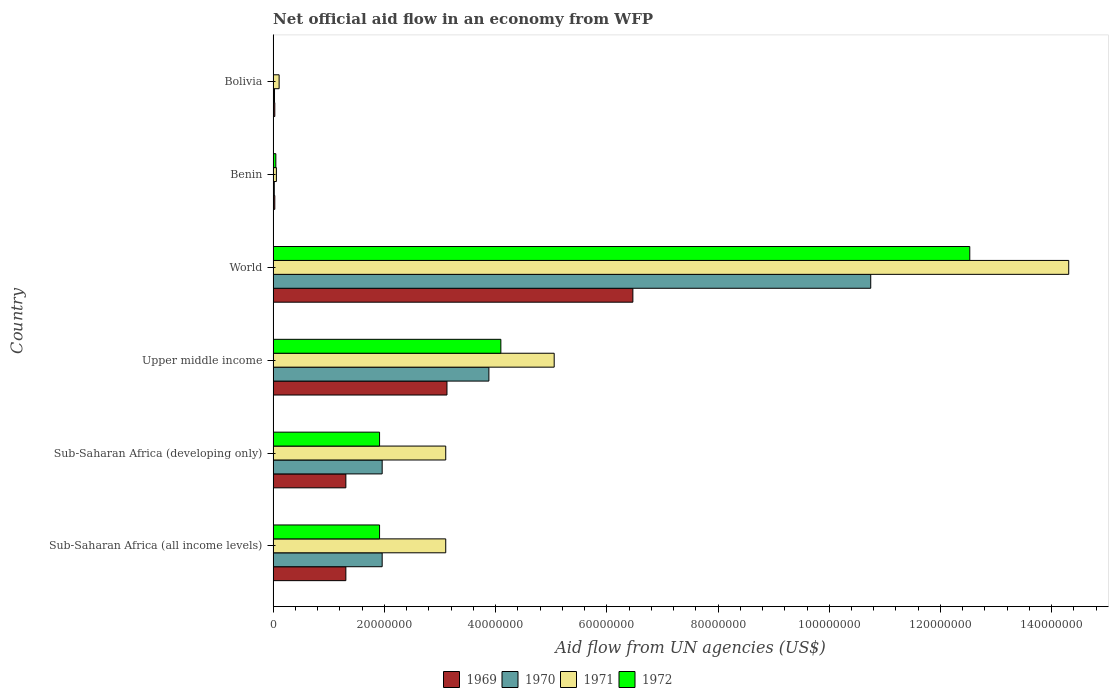How many different coloured bars are there?
Keep it short and to the point. 4. Are the number of bars per tick equal to the number of legend labels?
Provide a short and direct response. No. How many bars are there on the 3rd tick from the top?
Keep it short and to the point. 4. How many bars are there on the 2nd tick from the bottom?
Your answer should be compact. 4. What is the label of the 3rd group of bars from the top?
Offer a very short reply. World. What is the net official aid flow in 1969 in Sub-Saharan Africa (developing only)?
Your response must be concise. 1.31e+07. Across all countries, what is the maximum net official aid flow in 1971?
Your response must be concise. 1.43e+08. Across all countries, what is the minimum net official aid flow in 1969?
Give a very brief answer. 3.00e+05. In which country was the net official aid flow in 1972 maximum?
Offer a very short reply. World. What is the total net official aid flow in 1969 in the graph?
Offer a very short reply. 1.23e+08. What is the difference between the net official aid flow in 1969 in Bolivia and that in Sub-Saharan Africa (all income levels)?
Ensure brevity in your answer.  -1.28e+07. What is the difference between the net official aid flow in 1971 in Bolivia and the net official aid flow in 1970 in Upper middle income?
Keep it short and to the point. -3.77e+07. What is the average net official aid flow in 1970 per country?
Ensure brevity in your answer.  3.10e+07. In how many countries, is the net official aid flow in 1969 greater than 112000000 US$?
Provide a succinct answer. 0. What is the ratio of the net official aid flow in 1972 in Sub-Saharan Africa (developing only) to that in Upper middle income?
Provide a succinct answer. 0.47. Is the net official aid flow in 1972 in Benin less than that in Upper middle income?
Give a very brief answer. Yes. What is the difference between the highest and the second highest net official aid flow in 1969?
Provide a short and direct response. 3.34e+07. What is the difference between the highest and the lowest net official aid flow in 1972?
Give a very brief answer. 1.25e+08. Is the sum of the net official aid flow in 1970 in Sub-Saharan Africa (all income levels) and Sub-Saharan Africa (developing only) greater than the maximum net official aid flow in 1972 across all countries?
Give a very brief answer. No. How many bars are there?
Your answer should be compact. 23. How many countries are there in the graph?
Keep it short and to the point. 6. Are the values on the major ticks of X-axis written in scientific E-notation?
Keep it short and to the point. No. How many legend labels are there?
Ensure brevity in your answer.  4. What is the title of the graph?
Provide a short and direct response. Net official aid flow in an economy from WFP. What is the label or title of the X-axis?
Your response must be concise. Aid flow from UN agencies (US$). What is the Aid flow from UN agencies (US$) of 1969 in Sub-Saharan Africa (all income levels)?
Your answer should be very brief. 1.31e+07. What is the Aid flow from UN agencies (US$) of 1970 in Sub-Saharan Africa (all income levels)?
Ensure brevity in your answer.  1.96e+07. What is the Aid flow from UN agencies (US$) in 1971 in Sub-Saharan Africa (all income levels)?
Your answer should be compact. 3.10e+07. What is the Aid flow from UN agencies (US$) in 1972 in Sub-Saharan Africa (all income levels)?
Your response must be concise. 1.91e+07. What is the Aid flow from UN agencies (US$) of 1969 in Sub-Saharan Africa (developing only)?
Provide a succinct answer. 1.31e+07. What is the Aid flow from UN agencies (US$) in 1970 in Sub-Saharan Africa (developing only)?
Your response must be concise. 1.96e+07. What is the Aid flow from UN agencies (US$) of 1971 in Sub-Saharan Africa (developing only)?
Make the answer very short. 3.10e+07. What is the Aid flow from UN agencies (US$) in 1972 in Sub-Saharan Africa (developing only)?
Provide a succinct answer. 1.91e+07. What is the Aid flow from UN agencies (US$) of 1969 in Upper middle income?
Keep it short and to the point. 3.13e+07. What is the Aid flow from UN agencies (US$) in 1970 in Upper middle income?
Keep it short and to the point. 3.88e+07. What is the Aid flow from UN agencies (US$) of 1971 in Upper middle income?
Offer a very short reply. 5.05e+07. What is the Aid flow from UN agencies (US$) in 1972 in Upper middle income?
Offer a very short reply. 4.10e+07. What is the Aid flow from UN agencies (US$) of 1969 in World?
Offer a terse response. 6.47e+07. What is the Aid flow from UN agencies (US$) of 1970 in World?
Your response must be concise. 1.07e+08. What is the Aid flow from UN agencies (US$) of 1971 in World?
Keep it short and to the point. 1.43e+08. What is the Aid flow from UN agencies (US$) of 1972 in World?
Offer a very short reply. 1.25e+08. What is the Aid flow from UN agencies (US$) of 1971 in Benin?
Make the answer very short. 5.90e+05. What is the Aid flow from UN agencies (US$) in 1972 in Benin?
Make the answer very short. 4.90e+05. What is the Aid flow from UN agencies (US$) in 1970 in Bolivia?
Your response must be concise. 2.50e+05. What is the Aid flow from UN agencies (US$) of 1971 in Bolivia?
Your answer should be very brief. 1.08e+06. Across all countries, what is the maximum Aid flow from UN agencies (US$) of 1969?
Provide a short and direct response. 6.47e+07. Across all countries, what is the maximum Aid flow from UN agencies (US$) in 1970?
Keep it short and to the point. 1.07e+08. Across all countries, what is the maximum Aid flow from UN agencies (US$) in 1971?
Keep it short and to the point. 1.43e+08. Across all countries, what is the maximum Aid flow from UN agencies (US$) of 1972?
Ensure brevity in your answer.  1.25e+08. Across all countries, what is the minimum Aid flow from UN agencies (US$) of 1970?
Your response must be concise. 2.10e+05. Across all countries, what is the minimum Aid flow from UN agencies (US$) of 1971?
Keep it short and to the point. 5.90e+05. Across all countries, what is the minimum Aid flow from UN agencies (US$) of 1972?
Offer a terse response. 0. What is the total Aid flow from UN agencies (US$) in 1969 in the graph?
Ensure brevity in your answer.  1.23e+08. What is the total Aid flow from UN agencies (US$) in 1970 in the graph?
Keep it short and to the point. 1.86e+08. What is the total Aid flow from UN agencies (US$) of 1971 in the graph?
Your answer should be compact. 2.57e+08. What is the total Aid flow from UN agencies (US$) of 1972 in the graph?
Offer a very short reply. 2.05e+08. What is the difference between the Aid flow from UN agencies (US$) in 1969 in Sub-Saharan Africa (all income levels) and that in Sub-Saharan Africa (developing only)?
Give a very brief answer. 0. What is the difference between the Aid flow from UN agencies (US$) in 1969 in Sub-Saharan Africa (all income levels) and that in Upper middle income?
Your response must be concise. -1.82e+07. What is the difference between the Aid flow from UN agencies (US$) in 1970 in Sub-Saharan Africa (all income levels) and that in Upper middle income?
Offer a terse response. -1.92e+07. What is the difference between the Aid flow from UN agencies (US$) of 1971 in Sub-Saharan Africa (all income levels) and that in Upper middle income?
Offer a terse response. -1.95e+07. What is the difference between the Aid flow from UN agencies (US$) of 1972 in Sub-Saharan Africa (all income levels) and that in Upper middle income?
Ensure brevity in your answer.  -2.18e+07. What is the difference between the Aid flow from UN agencies (US$) of 1969 in Sub-Saharan Africa (all income levels) and that in World?
Give a very brief answer. -5.16e+07. What is the difference between the Aid flow from UN agencies (US$) in 1970 in Sub-Saharan Africa (all income levels) and that in World?
Your response must be concise. -8.78e+07. What is the difference between the Aid flow from UN agencies (US$) of 1971 in Sub-Saharan Africa (all income levels) and that in World?
Provide a succinct answer. -1.12e+08. What is the difference between the Aid flow from UN agencies (US$) in 1972 in Sub-Saharan Africa (all income levels) and that in World?
Ensure brevity in your answer.  -1.06e+08. What is the difference between the Aid flow from UN agencies (US$) of 1969 in Sub-Saharan Africa (all income levels) and that in Benin?
Give a very brief answer. 1.28e+07. What is the difference between the Aid flow from UN agencies (US$) of 1970 in Sub-Saharan Africa (all income levels) and that in Benin?
Give a very brief answer. 1.94e+07. What is the difference between the Aid flow from UN agencies (US$) of 1971 in Sub-Saharan Africa (all income levels) and that in Benin?
Your response must be concise. 3.04e+07. What is the difference between the Aid flow from UN agencies (US$) of 1972 in Sub-Saharan Africa (all income levels) and that in Benin?
Offer a very short reply. 1.86e+07. What is the difference between the Aid flow from UN agencies (US$) of 1969 in Sub-Saharan Africa (all income levels) and that in Bolivia?
Offer a very short reply. 1.28e+07. What is the difference between the Aid flow from UN agencies (US$) in 1970 in Sub-Saharan Africa (all income levels) and that in Bolivia?
Keep it short and to the point. 1.94e+07. What is the difference between the Aid flow from UN agencies (US$) of 1971 in Sub-Saharan Africa (all income levels) and that in Bolivia?
Ensure brevity in your answer.  3.00e+07. What is the difference between the Aid flow from UN agencies (US$) in 1969 in Sub-Saharan Africa (developing only) and that in Upper middle income?
Your answer should be compact. -1.82e+07. What is the difference between the Aid flow from UN agencies (US$) in 1970 in Sub-Saharan Africa (developing only) and that in Upper middle income?
Your answer should be very brief. -1.92e+07. What is the difference between the Aid flow from UN agencies (US$) in 1971 in Sub-Saharan Africa (developing only) and that in Upper middle income?
Provide a succinct answer. -1.95e+07. What is the difference between the Aid flow from UN agencies (US$) in 1972 in Sub-Saharan Africa (developing only) and that in Upper middle income?
Ensure brevity in your answer.  -2.18e+07. What is the difference between the Aid flow from UN agencies (US$) of 1969 in Sub-Saharan Africa (developing only) and that in World?
Make the answer very short. -5.16e+07. What is the difference between the Aid flow from UN agencies (US$) in 1970 in Sub-Saharan Africa (developing only) and that in World?
Offer a very short reply. -8.78e+07. What is the difference between the Aid flow from UN agencies (US$) in 1971 in Sub-Saharan Africa (developing only) and that in World?
Your answer should be very brief. -1.12e+08. What is the difference between the Aid flow from UN agencies (US$) in 1972 in Sub-Saharan Africa (developing only) and that in World?
Provide a short and direct response. -1.06e+08. What is the difference between the Aid flow from UN agencies (US$) in 1969 in Sub-Saharan Africa (developing only) and that in Benin?
Make the answer very short. 1.28e+07. What is the difference between the Aid flow from UN agencies (US$) of 1970 in Sub-Saharan Africa (developing only) and that in Benin?
Offer a terse response. 1.94e+07. What is the difference between the Aid flow from UN agencies (US$) in 1971 in Sub-Saharan Africa (developing only) and that in Benin?
Offer a very short reply. 3.04e+07. What is the difference between the Aid flow from UN agencies (US$) of 1972 in Sub-Saharan Africa (developing only) and that in Benin?
Offer a very short reply. 1.86e+07. What is the difference between the Aid flow from UN agencies (US$) in 1969 in Sub-Saharan Africa (developing only) and that in Bolivia?
Keep it short and to the point. 1.28e+07. What is the difference between the Aid flow from UN agencies (US$) in 1970 in Sub-Saharan Africa (developing only) and that in Bolivia?
Provide a succinct answer. 1.94e+07. What is the difference between the Aid flow from UN agencies (US$) in 1971 in Sub-Saharan Africa (developing only) and that in Bolivia?
Ensure brevity in your answer.  3.00e+07. What is the difference between the Aid flow from UN agencies (US$) of 1969 in Upper middle income and that in World?
Keep it short and to the point. -3.34e+07. What is the difference between the Aid flow from UN agencies (US$) of 1970 in Upper middle income and that in World?
Offer a terse response. -6.87e+07. What is the difference between the Aid flow from UN agencies (US$) of 1971 in Upper middle income and that in World?
Give a very brief answer. -9.25e+07. What is the difference between the Aid flow from UN agencies (US$) of 1972 in Upper middle income and that in World?
Your answer should be compact. -8.43e+07. What is the difference between the Aid flow from UN agencies (US$) of 1969 in Upper middle income and that in Benin?
Your answer should be very brief. 3.10e+07. What is the difference between the Aid flow from UN agencies (US$) in 1970 in Upper middle income and that in Benin?
Keep it short and to the point. 3.86e+07. What is the difference between the Aid flow from UN agencies (US$) of 1971 in Upper middle income and that in Benin?
Your answer should be compact. 5.00e+07. What is the difference between the Aid flow from UN agencies (US$) in 1972 in Upper middle income and that in Benin?
Your answer should be compact. 4.05e+07. What is the difference between the Aid flow from UN agencies (US$) in 1969 in Upper middle income and that in Bolivia?
Your answer should be compact. 3.10e+07. What is the difference between the Aid flow from UN agencies (US$) of 1970 in Upper middle income and that in Bolivia?
Offer a terse response. 3.86e+07. What is the difference between the Aid flow from UN agencies (US$) in 1971 in Upper middle income and that in Bolivia?
Keep it short and to the point. 4.95e+07. What is the difference between the Aid flow from UN agencies (US$) in 1969 in World and that in Benin?
Your answer should be very brief. 6.44e+07. What is the difference between the Aid flow from UN agencies (US$) in 1970 in World and that in Benin?
Offer a very short reply. 1.07e+08. What is the difference between the Aid flow from UN agencies (US$) of 1971 in World and that in Benin?
Ensure brevity in your answer.  1.42e+08. What is the difference between the Aid flow from UN agencies (US$) of 1972 in World and that in Benin?
Offer a terse response. 1.25e+08. What is the difference between the Aid flow from UN agencies (US$) of 1969 in World and that in Bolivia?
Your answer should be compact. 6.44e+07. What is the difference between the Aid flow from UN agencies (US$) in 1970 in World and that in Bolivia?
Your answer should be very brief. 1.07e+08. What is the difference between the Aid flow from UN agencies (US$) of 1971 in World and that in Bolivia?
Your response must be concise. 1.42e+08. What is the difference between the Aid flow from UN agencies (US$) in 1969 in Benin and that in Bolivia?
Make the answer very short. 0. What is the difference between the Aid flow from UN agencies (US$) of 1970 in Benin and that in Bolivia?
Offer a terse response. -4.00e+04. What is the difference between the Aid flow from UN agencies (US$) of 1971 in Benin and that in Bolivia?
Provide a succinct answer. -4.90e+05. What is the difference between the Aid flow from UN agencies (US$) in 1969 in Sub-Saharan Africa (all income levels) and the Aid flow from UN agencies (US$) in 1970 in Sub-Saharan Africa (developing only)?
Make the answer very short. -6.53e+06. What is the difference between the Aid flow from UN agencies (US$) in 1969 in Sub-Saharan Africa (all income levels) and the Aid flow from UN agencies (US$) in 1971 in Sub-Saharan Africa (developing only)?
Provide a short and direct response. -1.80e+07. What is the difference between the Aid flow from UN agencies (US$) in 1969 in Sub-Saharan Africa (all income levels) and the Aid flow from UN agencies (US$) in 1972 in Sub-Saharan Africa (developing only)?
Provide a short and direct response. -6.06e+06. What is the difference between the Aid flow from UN agencies (US$) in 1970 in Sub-Saharan Africa (all income levels) and the Aid flow from UN agencies (US$) in 1971 in Sub-Saharan Africa (developing only)?
Your answer should be compact. -1.14e+07. What is the difference between the Aid flow from UN agencies (US$) of 1970 in Sub-Saharan Africa (all income levels) and the Aid flow from UN agencies (US$) of 1972 in Sub-Saharan Africa (developing only)?
Make the answer very short. 4.70e+05. What is the difference between the Aid flow from UN agencies (US$) in 1971 in Sub-Saharan Africa (all income levels) and the Aid flow from UN agencies (US$) in 1972 in Sub-Saharan Africa (developing only)?
Your answer should be very brief. 1.19e+07. What is the difference between the Aid flow from UN agencies (US$) of 1969 in Sub-Saharan Africa (all income levels) and the Aid flow from UN agencies (US$) of 1970 in Upper middle income?
Offer a very short reply. -2.57e+07. What is the difference between the Aid flow from UN agencies (US$) in 1969 in Sub-Saharan Africa (all income levels) and the Aid flow from UN agencies (US$) in 1971 in Upper middle income?
Offer a terse response. -3.75e+07. What is the difference between the Aid flow from UN agencies (US$) of 1969 in Sub-Saharan Africa (all income levels) and the Aid flow from UN agencies (US$) of 1972 in Upper middle income?
Offer a terse response. -2.79e+07. What is the difference between the Aid flow from UN agencies (US$) of 1970 in Sub-Saharan Africa (all income levels) and the Aid flow from UN agencies (US$) of 1971 in Upper middle income?
Provide a succinct answer. -3.09e+07. What is the difference between the Aid flow from UN agencies (US$) of 1970 in Sub-Saharan Africa (all income levels) and the Aid flow from UN agencies (US$) of 1972 in Upper middle income?
Provide a short and direct response. -2.13e+07. What is the difference between the Aid flow from UN agencies (US$) in 1971 in Sub-Saharan Africa (all income levels) and the Aid flow from UN agencies (US$) in 1972 in Upper middle income?
Provide a succinct answer. -9.91e+06. What is the difference between the Aid flow from UN agencies (US$) in 1969 in Sub-Saharan Africa (all income levels) and the Aid flow from UN agencies (US$) in 1970 in World?
Offer a very short reply. -9.44e+07. What is the difference between the Aid flow from UN agencies (US$) of 1969 in Sub-Saharan Africa (all income levels) and the Aid flow from UN agencies (US$) of 1971 in World?
Ensure brevity in your answer.  -1.30e+08. What is the difference between the Aid flow from UN agencies (US$) in 1969 in Sub-Saharan Africa (all income levels) and the Aid flow from UN agencies (US$) in 1972 in World?
Offer a terse response. -1.12e+08. What is the difference between the Aid flow from UN agencies (US$) in 1970 in Sub-Saharan Africa (all income levels) and the Aid flow from UN agencies (US$) in 1971 in World?
Keep it short and to the point. -1.23e+08. What is the difference between the Aid flow from UN agencies (US$) in 1970 in Sub-Saharan Africa (all income levels) and the Aid flow from UN agencies (US$) in 1972 in World?
Give a very brief answer. -1.06e+08. What is the difference between the Aid flow from UN agencies (US$) of 1971 in Sub-Saharan Africa (all income levels) and the Aid flow from UN agencies (US$) of 1972 in World?
Offer a terse response. -9.42e+07. What is the difference between the Aid flow from UN agencies (US$) in 1969 in Sub-Saharan Africa (all income levels) and the Aid flow from UN agencies (US$) in 1970 in Benin?
Make the answer very short. 1.29e+07. What is the difference between the Aid flow from UN agencies (US$) in 1969 in Sub-Saharan Africa (all income levels) and the Aid flow from UN agencies (US$) in 1971 in Benin?
Your response must be concise. 1.25e+07. What is the difference between the Aid flow from UN agencies (US$) of 1969 in Sub-Saharan Africa (all income levels) and the Aid flow from UN agencies (US$) of 1972 in Benin?
Offer a very short reply. 1.26e+07. What is the difference between the Aid flow from UN agencies (US$) in 1970 in Sub-Saharan Africa (all income levels) and the Aid flow from UN agencies (US$) in 1971 in Benin?
Give a very brief answer. 1.90e+07. What is the difference between the Aid flow from UN agencies (US$) in 1970 in Sub-Saharan Africa (all income levels) and the Aid flow from UN agencies (US$) in 1972 in Benin?
Ensure brevity in your answer.  1.91e+07. What is the difference between the Aid flow from UN agencies (US$) of 1971 in Sub-Saharan Africa (all income levels) and the Aid flow from UN agencies (US$) of 1972 in Benin?
Your response must be concise. 3.06e+07. What is the difference between the Aid flow from UN agencies (US$) of 1969 in Sub-Saharan Africa (all income levels) and the Aid flow from UN agencies (US$) of 1970 in Bolivia?
Ensure brevity in your answer.  1.28e+07. What is the difference between the Aid flow from UN agencies (US$) in 1970 in Sub-Saharan Africa (all income levels) and the Aid flow from UN agencies (US$) in 1971 in Bolivia?
Offer a very short reply. 1.85e+07. What is the difference between the Aid flow from UN agencies (US$) of 1969 in Sub-Saharan Africa (developing only) and the Aid flow from UN agencies (US$) of 1970 in Upper middle income?
Your response must be concise. -2.57e+07. What is the difference between the Aid flow from UN agencies (US$) in 1969 in Sub-Saharan Africa (developing only) and the Aid flow from UN agencies (US$) in 1971 in Upper middle income?
Ensure brevity in your answer.  -3.75e+07. What is the difference between the Aid flow from UN agencies (US$) of 1969 in Sub-Saharan Africa (developing only) and the Aid flow from UN agencies (US$) of 1972 in Upper middle income?
Offer a very short reply. -2.79e+07. What is the difference between the Aid flow from UN agencies (US$) of 1970 in Sub-Saharan Africa (developing only) and the Aid flow from UN agencies (US$) of 1971 in Upper middle income?
Give a very brief answer. -3.09e+07. What is the difference between the Aid flow from UN agencies (US$) in 1970 in Sub-Saharan Africa (developing only) and the Aid flow from UN agencies (US$) in 1972 in Upper middle income?
Offer a very short reply. -2.13e+07. What is the difference between the Aid flow from UN agencies (US$) in 1971 in Sub-Saharan Africa (developing only) and the Aid flow from UN agencies (US$) in 1972 in Upper middle income?
Provide a short and direct response. -9.91e+06. What is the difference between the Aid flow from UN agencies (US$) of 1969 in Sub-Saharan Africa (developing only) and the Aid flow from UN agencies (US$) of 1970 in World?
Your answer should be very brief. -9.44e+07. What is the difference between the Aid flow from UN agencies (US$) in 1969 in Sub-Saharan Africa (developing only) and the Aid flow from UN agencies (US$) in 1971 in World?
Your answer should be very brief. -1.30e+08. What is the difference between the Aid flow from UN agencies (US$) of 1969 in Sub-Saharan Africa (developing only) and the Aid flow from UN agencies (US$) of 1972 in World?
Ensure brevity in your answer.  -1.12e+08. What is the difference between the Aid flow from UN agencies (US$) in 1970 in Sub-Saharan Africa (developing only) and the Aid flow from UN agencies (US$) in 1971 in World?
Your answer should be compact. -1.23e+08. What is the difference between the Aid flow from UN agencies (US$) in 1970 in Sub-Saharan Africa (developing only) and the Aid flow from UN agencies (US$) in 1972 in World?
Keep it short and to the point. -1.06e+08. What is the difference between the Aid flow from UN agencies (US$) in 1971 in Sub-Saharan Africa (developing only) and the Aid flow from UN agencies (US$) in 1972 in World?
Offer a very short reply. -9.42e+07. What is the difference between the Aid flow from UN agencies (US$) in 1969 in Sub-Saharan Africa (developing only) and the Aid flow from UN agencies (US$) in 1970 in Benin?
Ensure brevity in your answer.  1.29e+07. What is the difference between the Aid flow from UN agencies (US$) in 1969 in Sub-Saharan Africa (developing only) and the Aid flow from UN agencies (US$) in 1971 in Benin?
Provide a succinct answer. 1.25e+07. What is the difference between the Aid flow from UN agencies (US$) of 1969 in Sub-Saharan Africa (developing only) and the Aid flow from UN agencies (US$) of 1972 in Benin?
Your answer should be very brief. 1.26e+07. What is the difference between the Aid flow from UN agencies (US$) in 1970 in Sub-Saharan Africa (developing only) and the Aid flow from UN agencies (US$) in 1971 in Benin?
Keep it short and to the point. 1.90e+07. What is the difference between the Aid flow from UN agencies (US$) in 1970 in Sub-Saharan Africa (developing only) and the Aid flow from UN agencies (US$) in 1972 in Benin?
Offer a terse response. 1.91e+07. What is the difference between the Aid flow from UN agencies (US$) of 1971 in Sub-Saharan Africa (developing only) and the Aid flow from UN agencies (US$) of 1972 in Benin?
Your answer should be compact. 3.06e+07. What is the difference between the Aid flow from UN agencies (US$) in 1969 in Sub-Saharan Africa (developing only) and the Aid flow from UN agencies (US$) in 1970 in Bolivia?
Offer a very short reply. 1.28e+07. What is the difference between the Aid flow from UN agencies (US$) of 1970 in Sub-Saharan Africa (developing only) and the Aid flow from UN agencies (US$) of 1971 in Bolivia?
Ensure brevity in your answer.  1.85e+07. What is the difference between the Aid flow from UN agencies (US$) in 1969 in Upper middle income and the Aid flow from UN agencies (US$) in 1970 in World?
Make the answer very short. -7.62e+07. What is the difference between the Aid flow from UN agencies (US$) in 1969 in Upper middle income and the Aid flow from UN agencies (US$) in 1971 in World?
Give a very brief answer. -1.12e+08. What is the difference between the Aid flow from UN agencies (US$) in 1969 in Upper middle income and the Aid flow from UN agencies (US$) in 1972 in World?
Make the answer very short. -9.40e+07. What is the difference between the Aid flow from UN agencies (US$) of 1970 in Upper middle income and the Aid flow from UN agencies (US$) of 1971 in World?
Ensure brevity in your answer.  -1.04e+08. What is the difference between the Aid flow from UN agencies (US$) in 1970 in Upper middle income and the Aid flow from UN agencies (US$) in 1972 in World?
Give a very brief answer. -8.65e+07. What is the difference between the Aid flow from UN agencies (US$) in 1971 in Upper middle income and the Aid flow from UN agencies (US$) in 1972 in World?
Keep it short and to the point. -7.47e+07. What is the difference between the Aid flow from UN agencies (US$) in 1969 in Upper middle income and the Aid flow from UN agencies (US$) in 1970 in Benin?
Give a very brief answer. 3.10e+07. What is the difference between the Aid flow from UN agencies (US$) of 1969 in Upper middle income and the Aid flow from UN agencies (US$) of 1971 in Benin?
Give a very brief answer. 3.07e+07. What is the difference between the Aid flow from UN agencies (US$) in 1969 in Upper middle income and the Aid flow from UN agencies (US$) in 1972 in Benin?
Make the answer very short. 3.08e+07. What is the difference between the Aid flow from UN agencies (US$) in 1970 in Upper middle income and the Aid flow from UN agencies (US$) in 1971 in Benin?
Keep it short and to the point. 3.82e+07. What is the difference between the Aid flow from UN agencies (US$) of 1970 in Upper middle income and the Aid flow from UN agencies (US$) of 1972 in Benin?
Offer a terse response. 3.83e+07. What is the difference between the Aid flow from UN agencies (US$) in 1971 in Upper middle income and the Aid flow from UN agencies (US$) in 1972 in Benin?
Your response must be concise. 5.00e+07. What is the difference between the Aid flow from UN agencies (US$) of 1969 in Upper middle income and the Aid flow from UN agencies (US$) of 1970 in Bolivia?
Your answer should be very brief. 3.10e+07. What is the difference between the Aid flow from UN agencies (US$) of 1969 in Upper middle income and the Aid flow from UN agencies (US$) of 1971 in Bolivia?
Make the answer very short. 3.02e+07. What is the difference between the Aid flow from UN agencies (US$) of 1970 in Upper middle income and the Aid flow from UN agencies (US$) of 1971 in Bolivia?
Your answer should be very brief. 3.77e+07. What is the difference between the Aid flow from UN agencies (US$) in 1969 in World and the Aid flow from UN agencies (US$) in 1970 in Benin?
Give a very brief answer. 6.45e+07. What is the difference between the Aid flow from UN agencies (US$) of 1969 in World and the Aid flow from UN agencies (US$) of 1971 in Benin?
Keep it short and to the point. 6.41e+07. What is the difference between the Aid flow from UN agencies (US$) of 1969 in World and the Aid flow from UN agencies (US$) of 1972 in Benin?
Make the answer very short. 6.42e+07. What is the difference between the Aid flow from UN agencies (US$) in 1970 in World and the Aid flow from UN agencies (US$) in 1971 in Benin?
Your answer should be very brief. 1.07e+08. What is the difference between the Aid flow from UN agencies (US$) of 1970 in World and the Aid flow from UN agencies (US$) of 1972 in Benin?
Offer a terse response. 1.07e+08. What is the difference between the Aid flow from UN agencies (US$) of 1971 in World and the Aid flow from UN agencies (US$) of 1972 in Benin?
Your answer should be very brief. 1.43e+08. What is the difference between the Aid flow from UN agencies (US$) in 1969 in World and the Aid flow from UN agencies (US$) in 1970 in Bolivia?
Your answer should be compact. 6.44e+07. What is the difference between the Aid flow from UN agencies (US$) in 1969 in World and the Aid flow from UN agencies (US$) in 1971 in Bolivia?
Ensure brevity in your answer.  6.36e+07. What is the difference between the Aid flow from UN agencies (US$) in 1970 in World and the Aid flow from UN agencies (US$) in 1971 in Bolivia?
Give a very brief answer. 1.06e+08. What is the difference between the Aid flow from UN agencies (US$) of 1969 in Benin and the Aid flow from UN agencies (US$) of 1970 in Bolivia?
Provide a succinct answer. 5.00e+04. What is the difference between the Aid flow from UN agencies (US$) in 1969 in Benin and the Aid flow from UN agencies (US$) in 1971 in Bolivia?
Provide a succinct answer. -7.80e+05. What is the difference between the Aid flow from UN agencies (US$) in 1970 in Benin and the Aid flow from UN agencies (US$) in 1971 in Bolivia?
Offer a terse response. -8.70e+05. What is the average Aid flow from UN agencies (US$) in 1969 per country?
Your answer should be very brief. 2.05e+07. What is the average Aid flow from UN agencies (US$) in 1970 per country?
Give a very brief answer. 3.10e+07. What is the average Aid flow from UN agencies (US$) in 1971 per country?
Make the answer very short. 4.29e+07. What is the average Aid flow from UN agencies (US$) in 1972 per country?
Make the answer very short. 3.42e+07. What is the difference between the Aid flow from UN agencies (US$) of 1969 and Aid flow from UN agencies (US$) of 1970 in Sub-Saharan Africa (all income levels)?
Your response must be concise. -6.53e+06. What is the difference between the Aid flow from UN agencies (US$) in 1969 and Aid flow from UN agencies (US$) in 1971 in Sub-Saharan Africa (all income levels)?
Keep it short and to the point. -1.80e+07. What is the difference between the Aid flow from UN agencies (US$) in 1969 and Aid flow from UN agencies (US$) in 1972 in Sub-Saharan Africa (all income levels)?
Your answer should be compact. -6.06e+06. What is the difference between the Aid flow from UN agencies (US$) of 1970 and Aid flow from UN agencies (US$) of 1971 in Sub-Saharan Africa (all income levels)?
Give a very brief answer. -1.14e+07. What is the difference between the Aid flow from UN agencies (US$) of 1971 and Aid flow from UN agencies (US$) of 1972 in Sub-Saharan Africa (all income levels)?
Ensure brevity in your answer.  1.19e+07. What is the difference between the Aid flow from UN agencies (US$) in 1969 and Aid flow from UN agencies (US$) in 1970 in Sub-Saharan Africa (developing only)?
Provide a succinct answer. -6.53e+06. What is the difference between the Aid flow from UN agencies (US$) in 1969 and Aid flow from UN agencies (US$) in 1971 in Sub-Saharan Africa (developing only)?
Provide a succinct answer. -1.80e+07. What is the difference between the Aid flow from UN agencies (US$) in 1969 and Aid flow from UN agencies (US$) in 1972 in Sub-Saharan Africa (developing only)?
Your response must be concise. -6.06e+06. What is the difference between the Aid flow from UN agencies (US$) in 1970 and Aid flow from UN agencies (US$) in 1971 in Sub-Saharan Africa (developing only)?
Provide a short and direct response. -1.14e+07. What is the difference between the Aid flow from UN agencies (US$) of 1971 and Aid flow from UN agencies (US$) of 1972 in Sub-Saharan Africa (developing only)?
Give a very brief answer. 1.19e+07. What is the difference between the Aid flow from UN agencies (US$) of 1969 and Aid flow from UN agencies (US$) of 1970 in Upper middle income?
Ensure brevity in your answer.  -7.54e+06. What is the difference between the Aid flow from UN agencies (US$) in 1969 and Aid flow from UN agencies (US$) in 1971 in Upper middle income?
Provide a succinct answer. -1.93e+07. What is the difference between the Aid flow from UN agencies (US$) in 1969 and Aid flow from UN agencies (US$) in 1972 in Upper middle income?
Provide a succinct answer. -9.69e+06. What is the difference between the Aid flow from UN agencies (US$) in 1970 and Aid flow from UN agencies (US$) in 1971 in Upper middle income?
Your response must be concise. -1.17e+07. What is the difference between the Aid flow from UN agencies (US$) in 1970 and Aid flow from UN agencies (US$) in 1972 in Upper middle income?
Your answer should be compact. -2.15e+06. What is the difference between the Aid flow from UN agencies (US$) in 1971 and Aid flow from UN agencies (US$) in 1972 in Upper middle income?
Your answer should be compact. 9.59e+06. What is the difference between the Aid flow from UN agencies (US$) of 1969 and Aid flow from UN agencies (US$) of 1970 in World?
Your answer should be compact. -4.28e+07. What is the difference between the Aid flow from UN agencies (US$) in 1969 and Aid flow from UN agencies (US$) in 1971 in World?
Offer a terse response. -7.84e+07. What is the difference between the Aid flow from UN agencies (US$) in 1969 and Aid flow from UN agencies (US$) in 1972 in World?
Keep it short and to the point. -6.06e+07. What is the difference between the Aid flow from UN agencies (US$) of 1970 and Aid flow from UN agencies (US$) of 1971 in World?
Your answer should be very brief. -3.56e+07. What is the difference between the Aid flow from UN agencies (US$) of 1970 and Aid flow from UN agencies (US$) of 1972 in World?
Make the answer very short. -1.78e+07. What is the difference between the Aid flow from UN agencies (US$) in 1971 and Aid flow from UN agencies (US$) in 1972 in World?
Provide a succinct answer. 1.78e+07. What is the difference between the Aid flow from UN agencies (US$) in 1969 and Aid flow from UN agencies (US$) in 1971 in Benin?
Keep it short and to the point. -2.90e+05. What is the difference between the Aid flow from UN agencies (US$) of 1969 and Aid flow from UN agencies (US$) of 1972 in Benin?
Offer a terse response. -1.90e+05. What is the difference between the Aid flow from UN agencies (US$) of 1970 and Aid flow from UN agencies (US$) of 1971 in Benin?
Ensure brevity in your answer.  -3.80e+05. What is the difference between the Aid flow from UN agencies (US$) in 1970 and Aid flow from UN agencies (US$) in 1972 in Benin?
Ensure brevity in your answer.  -2.80e+05. What is the difference between the Aid flow from UN agencies (US$) of 1969 and Aid flow from UN agencies (US$) of 1970 in Bolivia?
Offer a very short reply. 5.00e+04. What is the difference between the Aid flow from UN agencies (US$) of 1969 and Aid flow from UN agencies (US$) of 1971 in Bolivia?
Ensure brevity in your answer.  -7.80e+05. What is the difference between the Aid flow from UN agencies (US$) of 1970 and Aid flow from UN agencies (US$) of 1971 in Bolivia?
Offer a very short reply. -8.30e+05. What is the ratio of the Aid flow from UN agencies (US$) of 1969 in Sub-Saharan Africa (all income levels) to that in Sub-Saharan Africa (developing only)?
Provide a succinct answer. 1. What is the ratio of the Aid flow from UN agencies (US$) of 1970 in Sub-Saharan Africa (all income levels) to that in Sub-Saharan Africa (developing only)?
Offer a terse response. 1. What is the ratio of the Aid flow from UN agencies (US$) in 1972 in Sub-Saharan Africa (all income levels) to that in Sub-Saharan Africa (developing only)?
Offer a terse response. 1. What is the ratio of the Aid flow from UN agencies (US$) in 1969 in Sub-Saharan Africa (all income levels) to that in Upper middle income?
Provide a short and direct response. 0.42. What is the ratio of the Aid flow from UN agencies (US$) of 1970 in Sub-Saharan Africa (all income levels) to that in Upper middle income?
Offer a very short reply. 0.51. What is the ratio of the Aid flow from UN agencies (US$) in 1971 in Sub-Saharan Africa (all income levels) to that in Upper middle income?
Your response must be concise. 0.61. What is the ratio of the Aid flow from UN agencies (US$) of 1972 in Sub-Saharan Africa (all income levels) to that in Upper middle income?
Provide a short and direct response. 0.47. What is the ratio of the Aid flow from UN agencies (US$) of 1969 in Sub-Saharan Africa (all income levels) to that in World?
Provide a succinct answer. 0.2. What is the ratio of the Aid flow from UN agencies (US$) of 1970 in Sub-Saharan Africa (all income levels) to that in World?
Make the answer very short. 0.18. What is the ratio of the Aid flow from UN agencies (US$) of 1971 in Sub-Saharan Africa (all income levels) to that in World?
Your answer should be very brief. 0.22. What is the ratio of the Aid flow from UN agencies (US$) in 1972 in Sub-Saharan Africa (all income levels) to that in World?
Provide a succinct answer. 0.15. What is the ratio of the Aid flow from UN agencies (US$) of 1969 in Sub-Saharan Africa (all income levels) to that in Benin?
Ensure brevity in your answer.  43.6. What is the ratio of the Aid flow from UN agencies (US$) of 1970 in Sub-Saharan Africa (all income levels) to that in Benin?
Ensure brevity in your answer.  93.38. What is the ratio of the Aid flow from UN agencies (US$) in 1971 in Sub-Saharan Africa (all income levels) to that in Benin?
Offer a terse response. 52.61. What is the ratio of the Aid flow from UN agencies (US$) of 1972 in Sub-Saharan Africa (all income levels) to that in Benin?
Your response must be concise. 39.06. What is the ratio of the Aid flow from UN agencies (US$) in 1969 in Sub-Saharan Africa (all income levels) to that in Bolivia?
Provide a succinct answer. 43.6. What is the ratio of the Aid flow from UN agencies (US$) of 1970 in Sub-Saharan Africa (all income levels) to that in Bolivia?
Your answer should be compact. 78.44. What is the ratio of the Aid flow from UN agencies (US$) of 1971 in Sub-Saharan Africa (all income levels) to that in Bolivia?
Ensure brevity in your answer.  28.74. What is the ratio of the Aid flow from UN agencies (US$) of 1969 in Sub-Saharan Africa (developing only) to that in Upper middle income?
Keep it short and to the point. 0.42. What is the ratio of the Aid flow from UN agencies (US$) of 1970 in Sub-Saharan Africa (developing only) to that in Upper middle income?
Provide a short and direct response. 0.51. What is the ratio of the Aid flow from UN agencies (US$) in 1971 in Sub-Saharan Africa (developing only) to that in Upper middle income?
Make the answer very short. 0.61. What is the ratio of the Aid flow from UN agencies (US$) of 1972 in Sub-Saharan Africa (developing only) to that in Upper middle income?
Your response must be concise. 0.47. What is the ratio of the Aid flow from UN agencies (US$) of 1969 in Sub-Saharan Africa (developing only) to that in World?
Your answer should be compact. 0.2. What is the ratio of the Aid flow from UN agencies (US$) in 1970 in Sub-Saharan Africa (developing only) to that in World?
Offer a terse response. 0.18. What is the ratio of the Aid flow from UN agencies (US$) in 1971 in Sub-Saharan Africa (developing only) to that in World?
Provide a short and direct response. 0.22. What is the ratio of the Aid flow from UN agencies (US$) of 1972 in Sub-Saharan Africa (developing only) to that in World?
Your answer should be very brief. 0.15. What is the ratio of the Aid flow from UN agencies (US$) in 1969 in Sub-Saharan Africa (developing only) to that in Benin?
Make the answer very short. 43.6. What is the ratio of the Aid flow from UN agencies (US$) of 1970 in Sub-Saharan Africa (developing only) to that in Benin?
Give a very brief answer. 93.38. What is the ratio of the Aid flow from UN agencies (US$) in 1971 in Sub-Saharan Africa (developing only) to that in Benin?
Provide a short and direct response. 52.61. What is the ratio of the Aid flow from UN agencies (US$) in 1972 in Sub-Saharan Africa (developing only) to that in Benin?
Keep it short and to the point. 39.06. What is the ratio of the Aid flow from UN agencies (US$) in 1969 in Sub-Saharan Africa (developing only) to that in Bolivia?
Provide a succinct answer. 43.6. What is the ratio of the Aid flow from UN agencies (US$) of 1970 in Sub-Saharan Africa (developing only) to that in Bolivia?
Ensure brevity in your answer.  78.44. What is the ratio of the Aid flow from UN agencies (US$) in 1971 in Sub-Saharan Africa (developing only) to that in Bolivia?
Your answer should be compact. 28.74. What is the ratio of the Aid flow from UN agencies (US$) of 1969 in Upper middle income to that in World?
Provide a short and direct response. 0.48. What is the ratio of the Aid flow from UN agencies (US$) of 1970 in Upper middle income to that in World?
Provide a short and direct response. 0.36. What is the ratio of the Aid flow from UN agencies (US$) in 1971 in Upper middle income to that in World?
Your answer should be very brief. 0.35. What is the ratio of the Aid flow from UN agencies (US$) in 1972 in Upper middle income to that in World?
Provide a succinct answer. 0.33. What is the ratio of the Aid flow from UN agencies (US$) in 1969 in Upper middle income to that in Benin?
Ensure brevity in your answer.  104.2. What is the ratio of the Aid flow from UN agencies (US$) of 1970 in Upper middle income to that in Benin?
Your response must be concise. 184.76. What is the ratio of the Aid flow from UN agencies (US$) in 1971 in Upper middle income to that in Benin?
Keep it short and to the point. 85.66. What is the ratio of the Aid flow from UN agencies (US$) in 1972 in Upper middle income to that in Benin?
Offer a terse response. 83.57. What is the ratio of the Aid flow from UN agencies (US$) in 1969 in Upper middle income to that in Bolivia?
Your answer should be very brief. 104.2. What is the ratio of the Aid flow from UN agencies (US$) in 1970 in Upper middle income to that in Bolivia?
Offer a very short reply. 155.2. What is the ratio of the Aid flow from UN agencies (US$) in 1971 in Upper middle income to that in Bolivia?
Your response must be concise. 46.8. What is the ratio of the Aid flow from UN agencies (US$) of 1969 in World to that in Benin?
Offer a terse response. 215.63. What is the ratio of the Aid flow from UN agencies (US$) of 1970 in World to that in Benin?
Ensure brevity in your answer.  511.71. What is the ratio of the Aid flow from UN agencies (US$) in 1971 in World to that in Benin?
Offer a very short reply. 242.47. What is the ratio of the Aid flow from UN agencies (US$) of 1972 in World to that in Benin?
Offer a very short reply. 255.65. What is the ratio of the Aid flow from UN agencies (US$) in 1969 in World to that in Bolivia?
Offer a terse response. 215.63. What is the ratio of the Aid flow from UN agencies (US$) of 1970 in World to that in Bolivia?
Your answer should be very brief. 429.84. What is the ratio of the Aid flow from UN agencies (US$) of 1971 in World to that in Bolivia?
Provide a short and direct response. 132.46. What is the ratio of the Aid flow from UN agencies (US$) of 1969 in Benin to that in Bolivia?
Give a very brief answer. 1. What is the ratio of the Aid flow from UN agencies (US$) of 1970 in Benin to that in Bolivia?
Your answer should be very brief. 0.84. What is the ratio of the Aid flow from UN agencies (US$) in 1971 in Benin to that in Bolivia?
Offer a terse response. 0.55. What is the difference between the highest and the second highest Aid flow from UN agencies (US$) in 1969?
Keep it short and to the point. 3.34e+07. What is the difference between the highest and the second highest Aid flow from UN agencies (US$) of 1970?
Your answer should be very brief. 6.87e+07. What is the difference between the highest and the second highest Aid flow from UN agencies (US$) in 1971?
Offer a very short reply. 9.25e+07. What is the difference between the highest and the second highest Aid flow from UN agencies (US$) of 1972?
Offer a very short reply. 8.43e+07. What is the difference between the highest and the lowest Aid flow from UN agencies (US$) of 1969?
Your answer should be very brief. 6.44e+07. What is the difference between the highest and the lowest Aid flow from UN agencies (US$) of 1970?
Keep it short and to the point. 1.07e+08. What is the difference between the highest and the lowest Aid flow from UN agencies (US$) in 1971?
Ensure brevity in your answer.  1.42e+08. What is the difference between the highest and the lowest Aid flow from UN agencies (US$) in 1972?
Your response must be concise. 1.25e+08. 